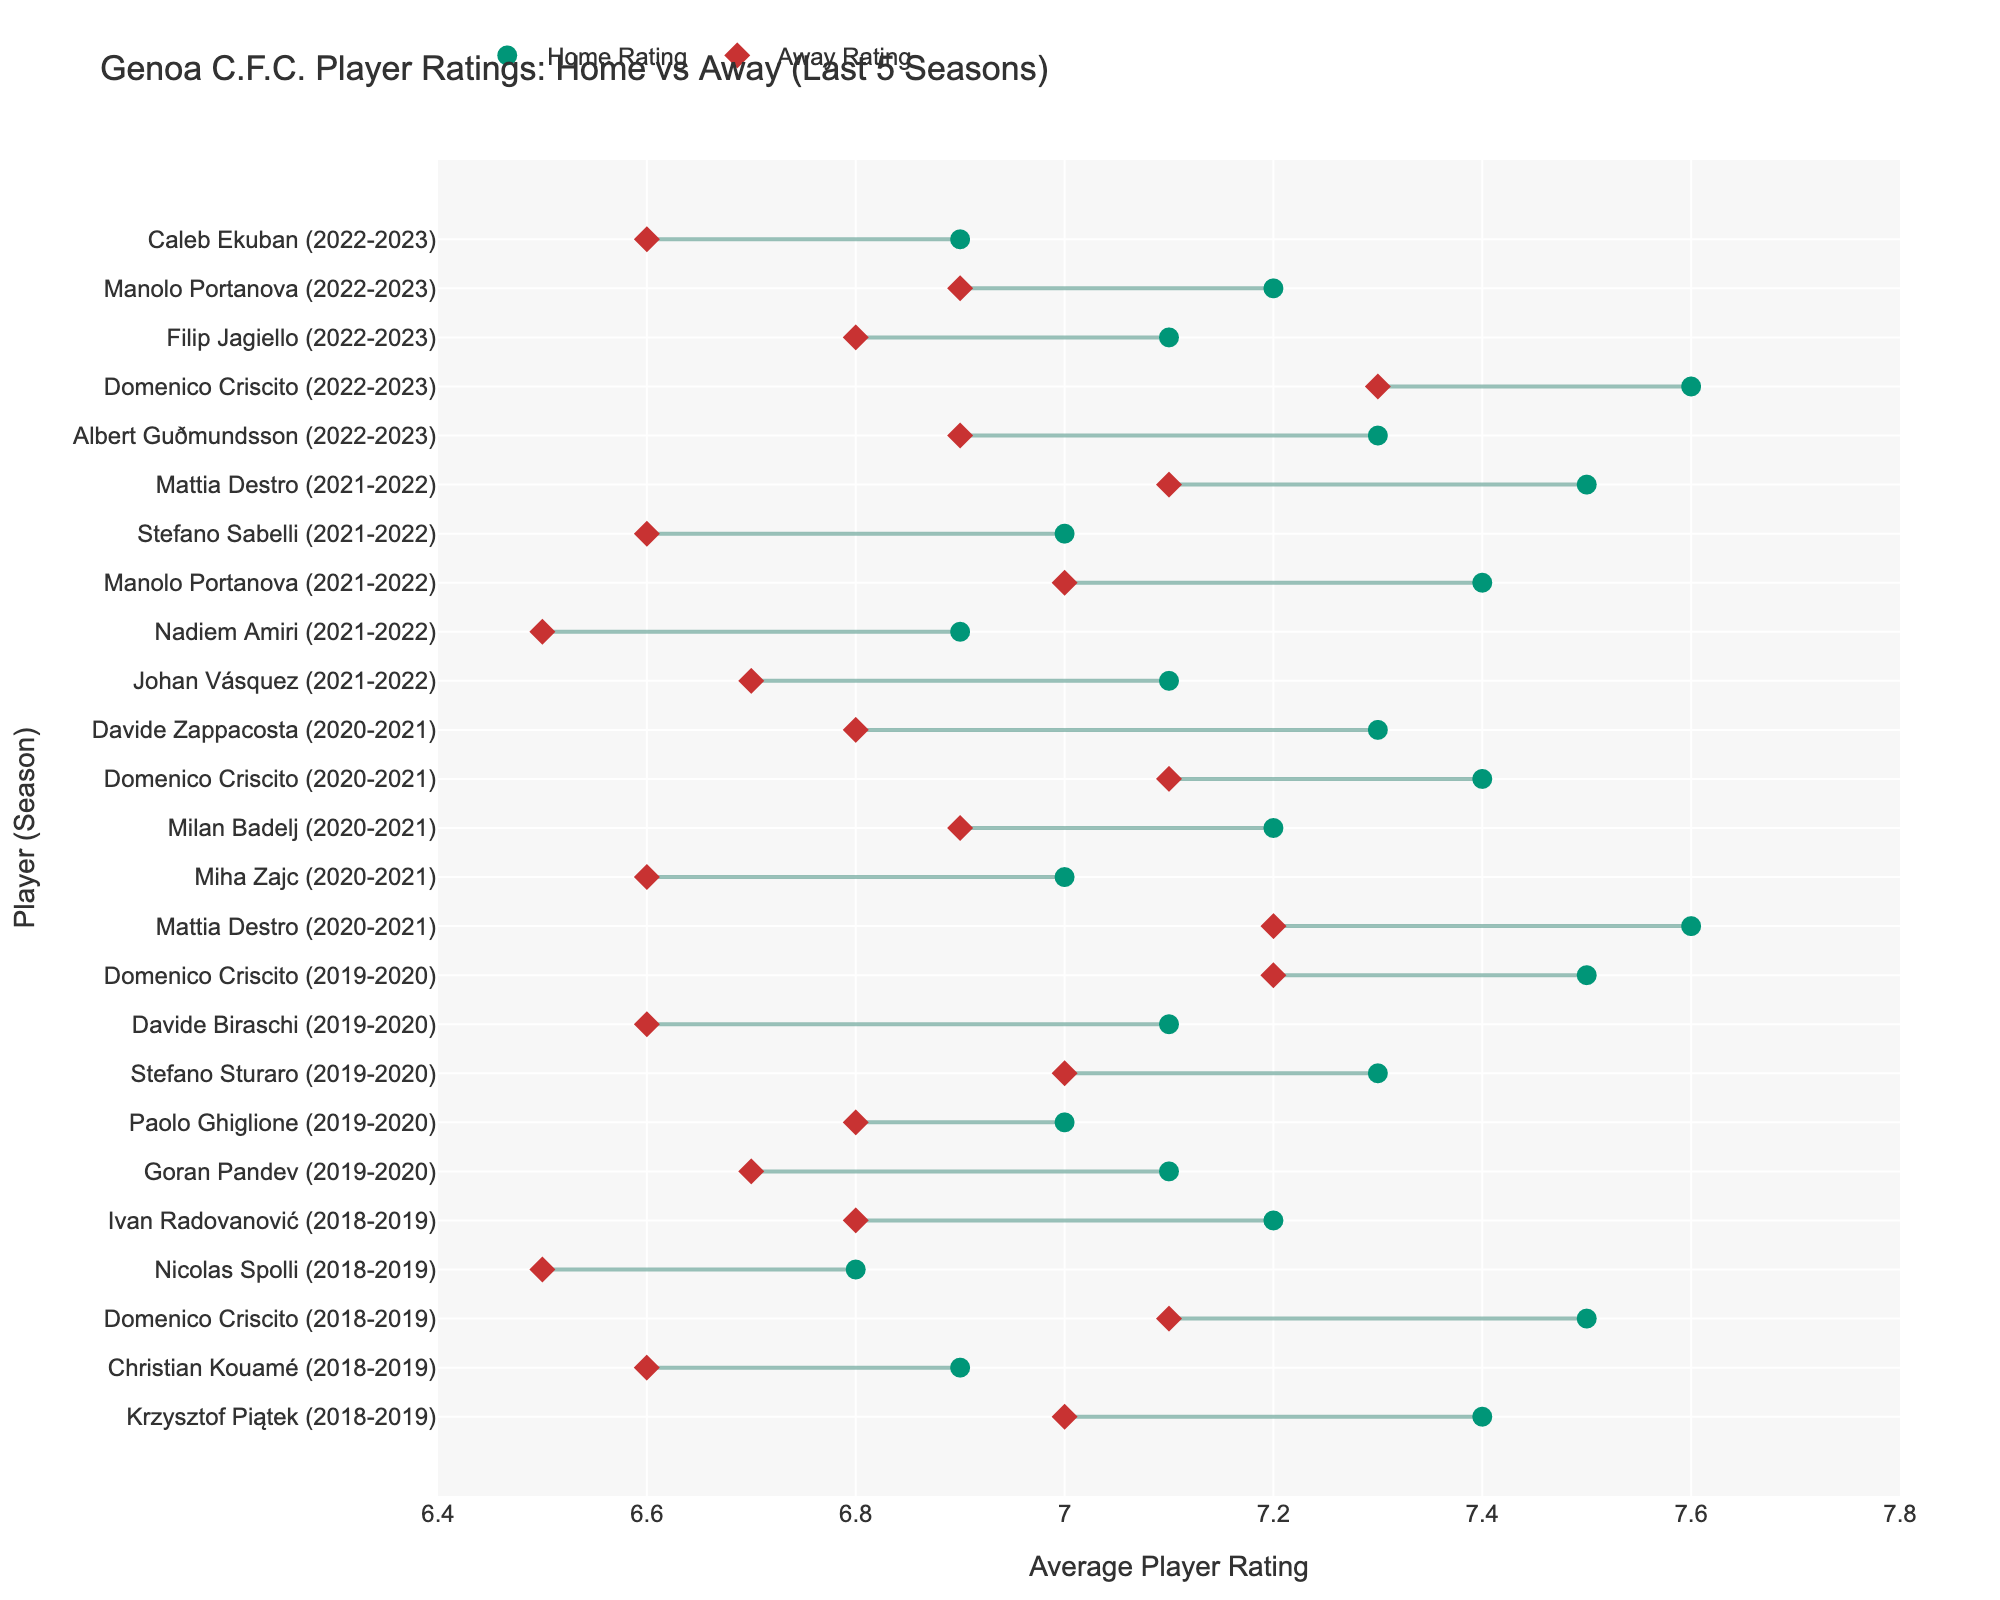Which player has the highest home rating in the 2018-2019 season? By examining the data points for the 2018-2019 season, look for the player with the highest home rating. Domenico Criscito has a home rating of 7.5, which is the highest in that season.
Answer: Domenico Criscito How does Krzysztof Piątek's home and away ratings compare in 2018-2019? To answer this, find Krzysztof Piątek's data points and compare his home rating (7.4) to his away rating (7.0). The home rating is higher by 0.4 points.
Answer: Home rating is higher by 0.4 Which player has the smallest difference between home and away ratings in the 2019-2020 season? Compare the differences between home and away ratings for each player in the 2019-2020 season. Paolo Ghiglione has the smallest difference (7.0 - 6.8 = 0.2).
Answer: Paolo Ghiglione What is the average home rating for Genoa C.F.C. players in the 2020-2021 season? Calculate the average of the home ratings for the listed players in the 2020-2021 season. Sum 7.6, 7.0, 7.2, 7.4, and 7.3, then divide by 5. The sum is 36.5, so the average is 36.5 / 5 = 7.3
Answer: 7.3 In which season did Domenico Criscito have the highest away rating? Look at Domenico Criscito's away ratings across the seasons. In 2022-2023, he has the highest away rating of 7.3.
Answer: 2022-2023 Which player's home rating improved the most from the 2020-2021 season to the 2022-2023 season? Compare home ratings for players present in both seasons. Mattia Destro has home ratings of 7.6 in 2020-2021 and 7.5 in 2021-2022; looking at other players, Domenico Criscito's home rating actually increased from 7.4 to 7.6. He had no improvement from 2020-2021 to 2022-2023 season from data given.
Answer: None What is the difference in home and away ratings for the average of all players in the 2021-2022 season? First calculate the average home rating, then the average away rating, and find the difference. Sum the home ratings (7.1 + 6.9 + 7.4 + 7.0 + 7.5 = 35.9), then the away ratings (6.7 + 6.5 + 7.0 + 6.6 + 7.1 = 33.9). The difference (35.9 - 33.9) is 2.
Answer: 2 Which player's performance is the most consistent between home and away games across all seasons? Consistency can be measured by the smallest difference between home and away ratings. Paolo Ghiglione (2019-2020) and Domenico Criscito (various seasons) show minimal differences of about 0.2 to 0.3. Paolo Ghiglione (0.2) is slightly more consistent.
Answer: Paolo Ghiglione (2019-2020) Which season has the highest average away rating across all players? Calculate the average away rating for each season. Sum and average the away ratings for each season, then compare. 2022-2023 has an average rating of (6.9 + 7.3 + 6.8 + 6.9 + 6.6) / 5 = 6.9. Comparatively, other seasons have lower averages.
Answer: 2022-2023 